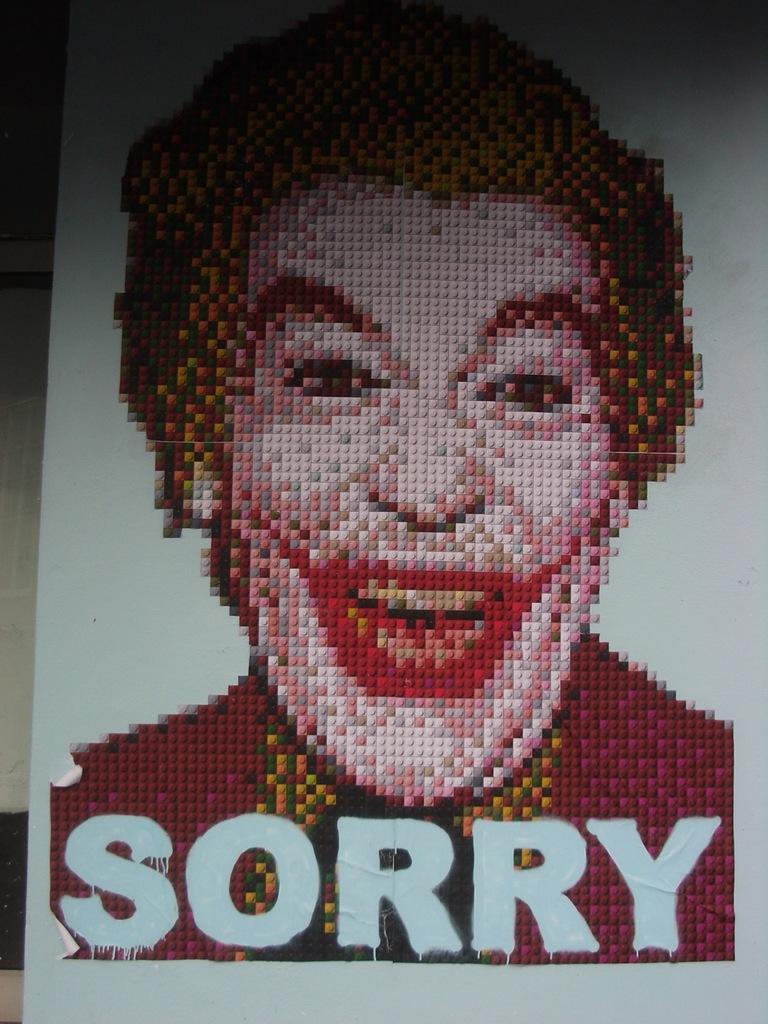In one or two sentences, can you explain what this image depicts? In this image we can see a board. In the center there is a man. At the bottom we can see a text. 